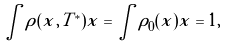Convert formula to latex. <formula><loc_0><loc_0><loc_500><loc_500>\int \rho ( x , T ^ { * } ) x = \int \rho _ { 0 } ( x ) x = 1 ,</formula> 